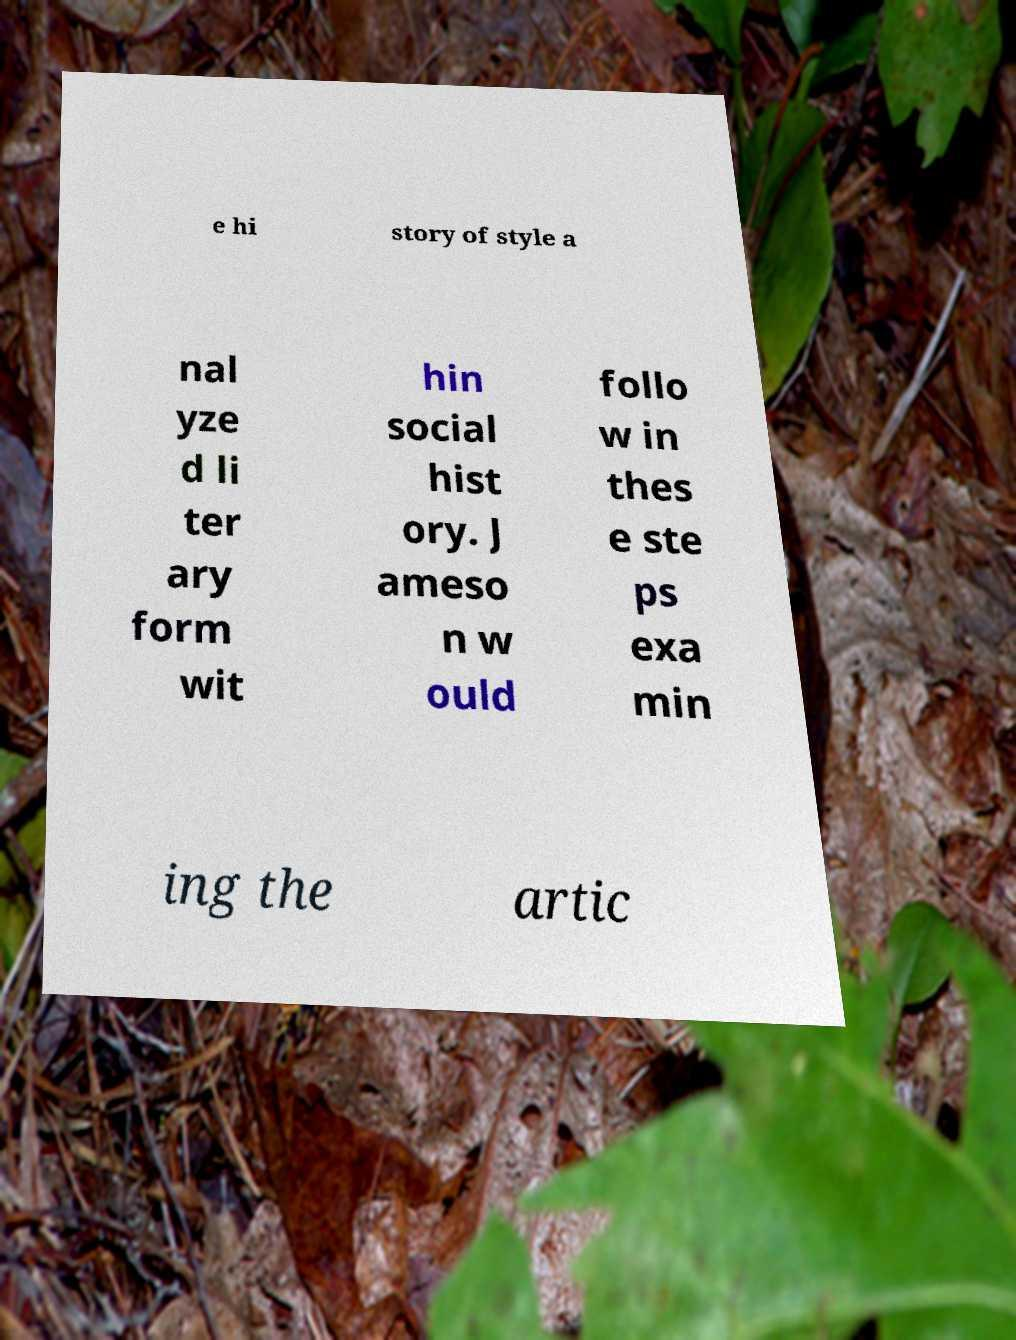Please identify and transcribe the text found in this image. e hi story of style a nal yze d li ter ary form wit hin social hist ory. J ameso n w ould follo w in thes e ste ps exa min ing the artic 